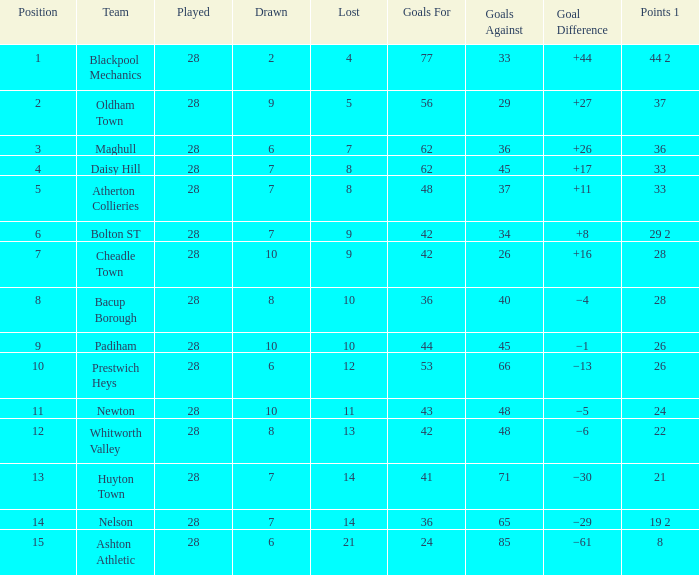What is the top goals entry with drawn more than 6 and goals against 85? None. 